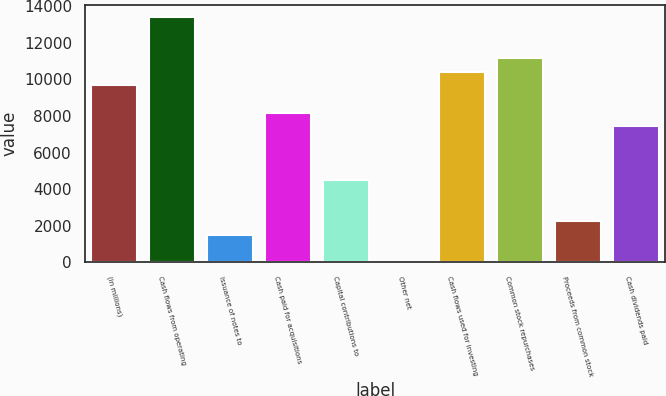Convert chart. <chart><loc_0><loc_0><loc_500><loc_500><bar_chart><fcel>(in millions)<fcel>Cash flows from operating<fcel>Issuance of notes to<fcel>Cash paid for acquisitions<fcel>Capital contributions to<fcel>Other net<fcel>Cash flows used for investing<fcel>Common stock repurchases<fcel>Proceeds from common stock<fcel>Cash dividends paid<nl><fcel>9675.8<fcel>13393.8<fcel>1496.2<fcel>8188.6<fcel>4470.6<fcel>9<fcel>10419.4<fcel>11163<fcel>2239.8<fcel>7445<nl></chart> 